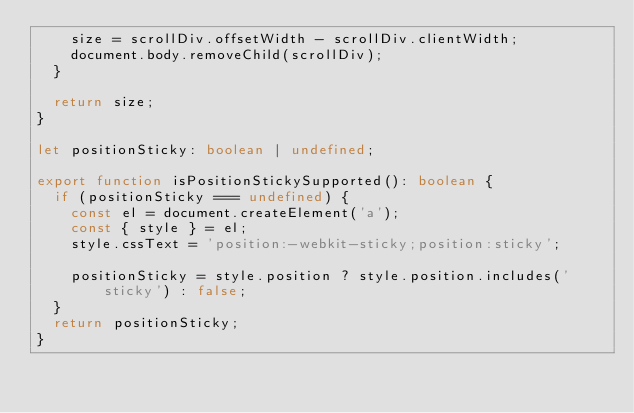Convert code to text. <code><loc_0><loc_0><loc_500><loc_500><_TypeScript_>    size = scrollDiv.offsetWidth - scrollDiv.clientWidth;
    document.body.removeChild(scrollDiv);
  }

  return size;
}

let positionSticky: boolean | undefined;

export function isPositionStickySupported(): boolean {
  if (positionSticky === undefined) {
    const el = document.createElement('a');
    const { style } = el;
    style.cssText = 'position:-webkit-sticky;position:sticky';

    positionSticky = style.position ? style.position.includes('sticky') : false;
  }
  return positionSticky;
}
</code> 